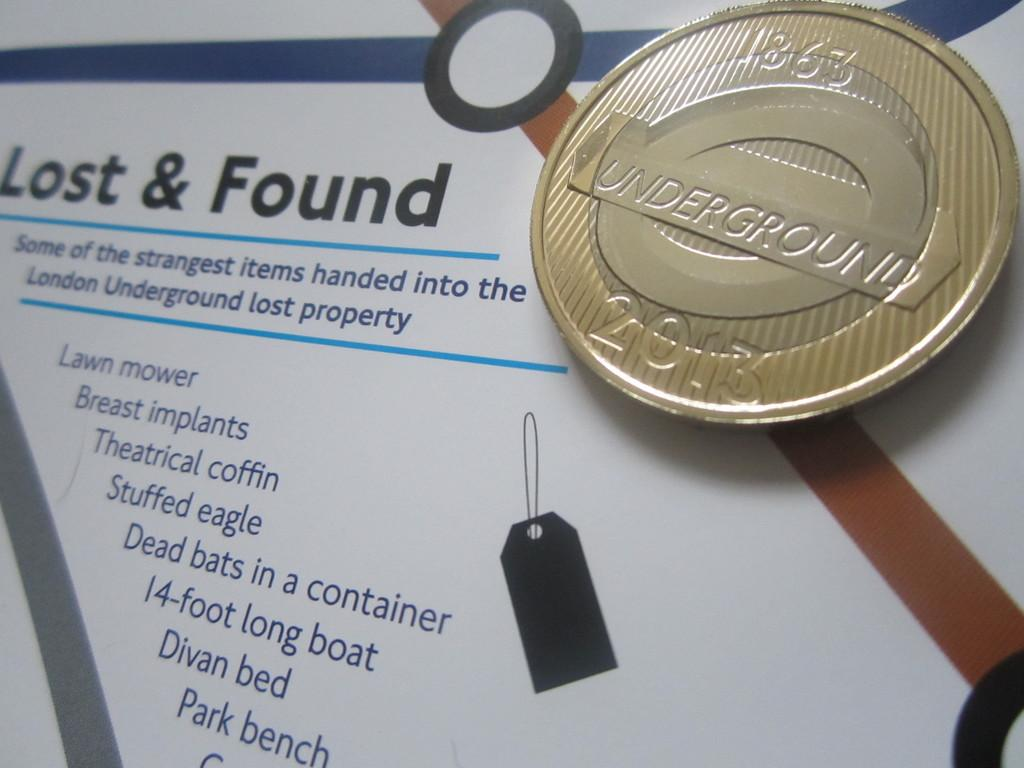<image>
Offer a succinct explanation of the picture presented. A piece of paper that says Lost & Found with various information it and a coin on top that says Underground 2013 on it 